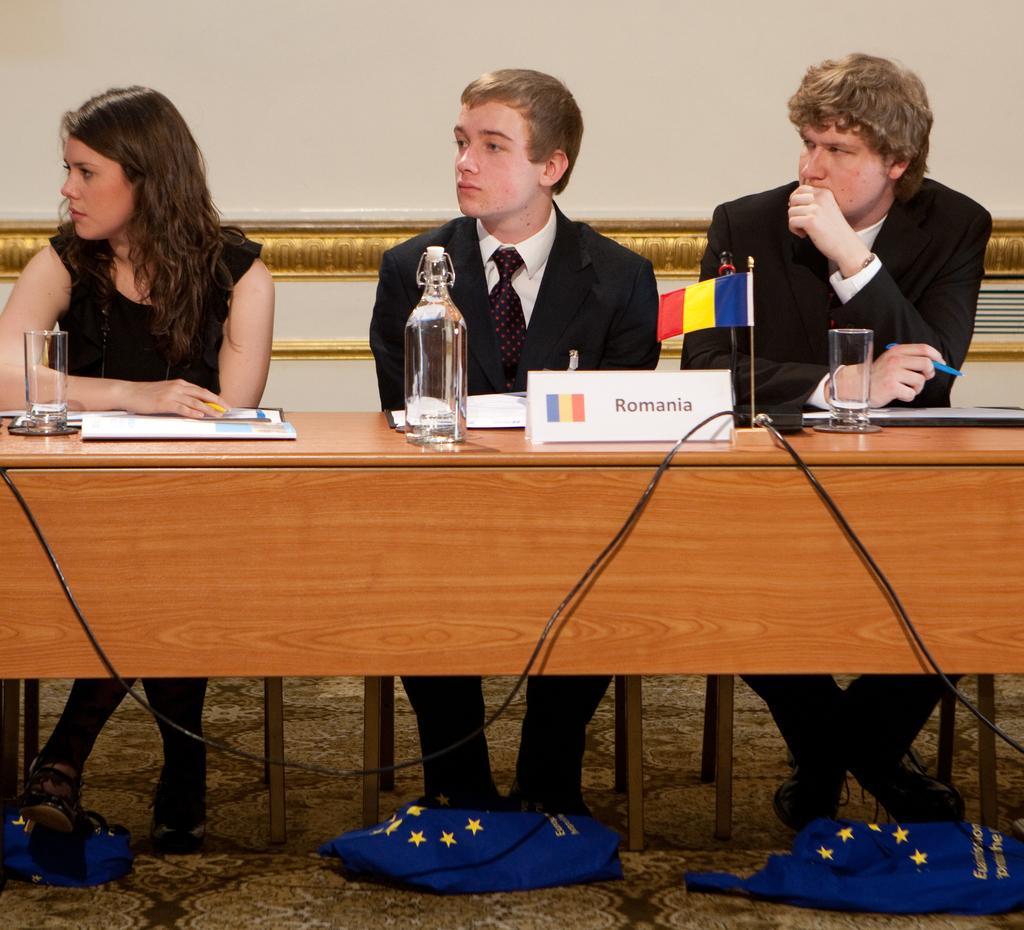Describe this image in one or two sentences. This image is taken inside a room. In this image there are three people a woman and two men sitting on the chairs. In the image there is a table with glass, bottle, name board, flag and few papers on it. In the background there is a wall. In the bottom of the image there is a floor with mat. 